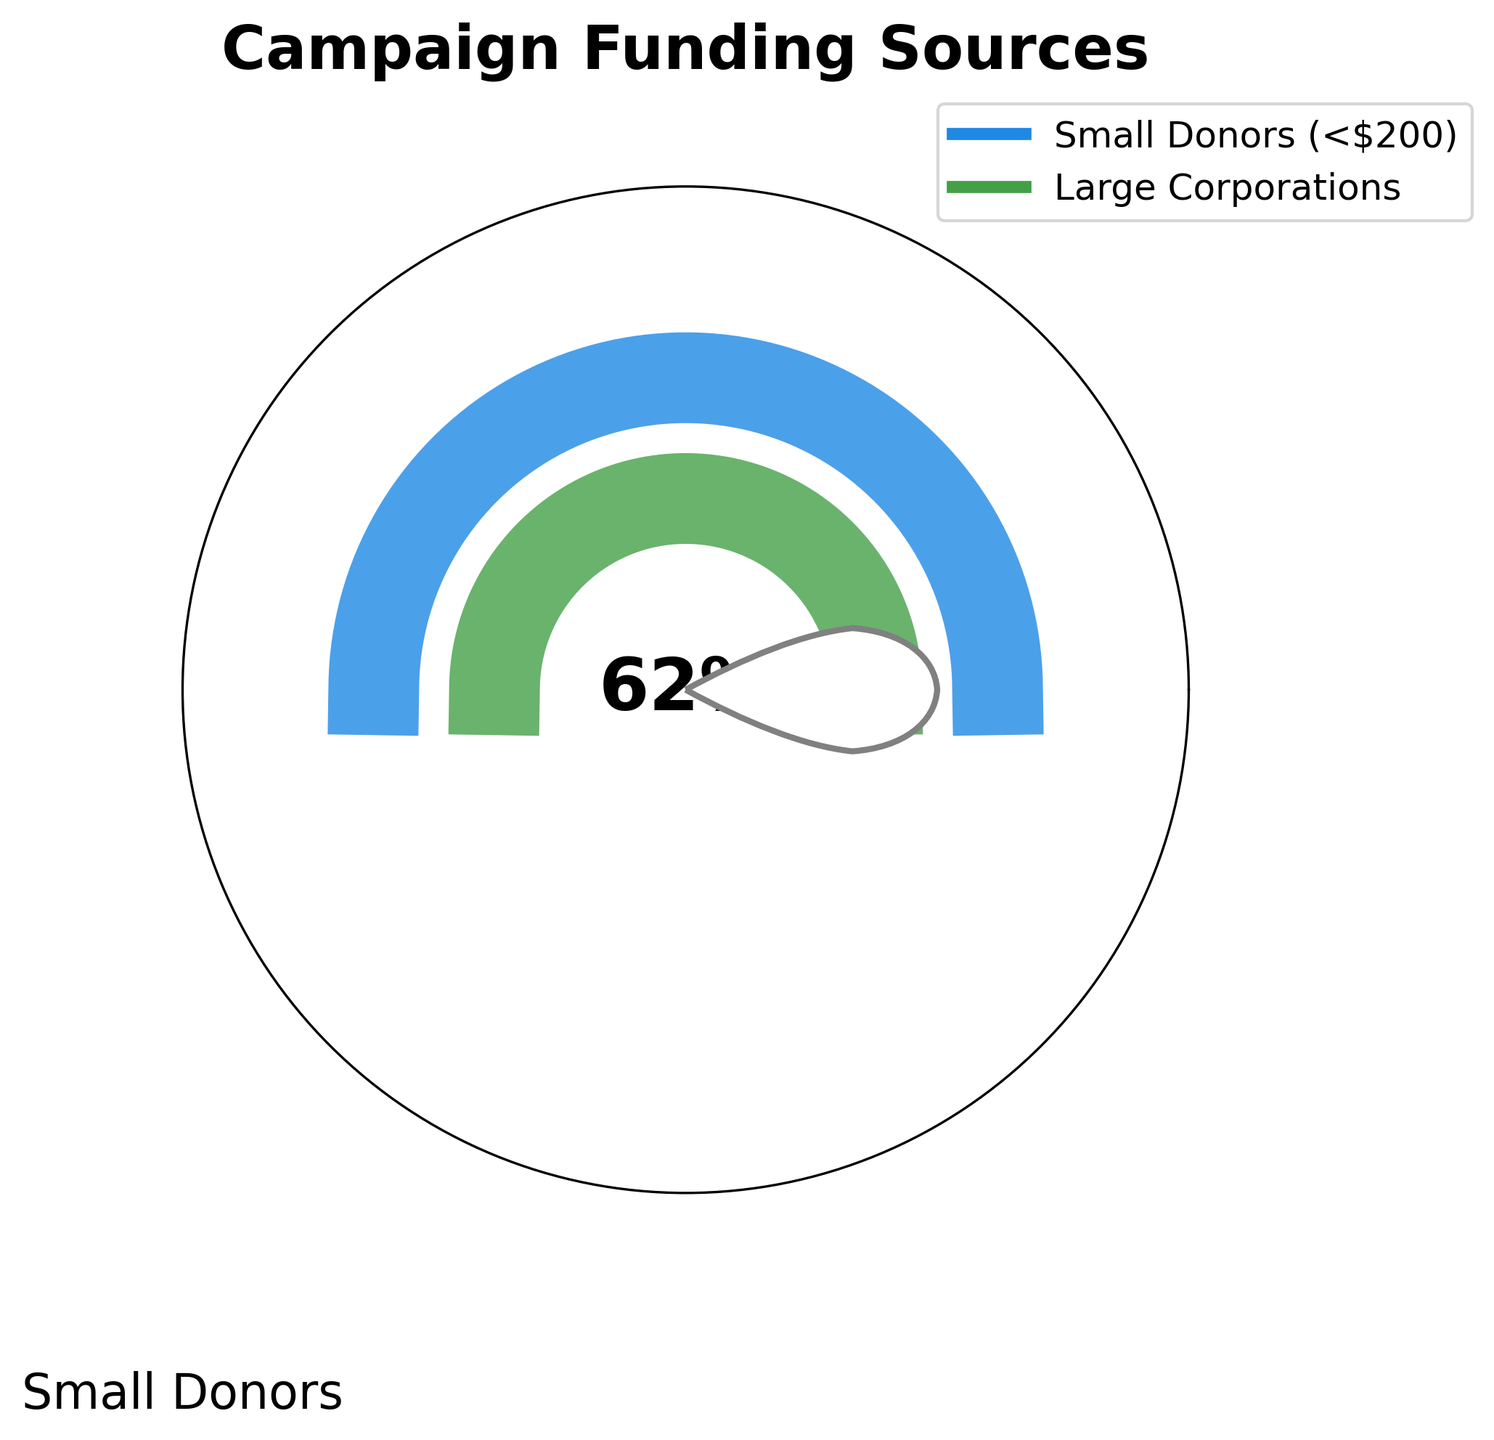what is the percentage of campaign funding from small donors? The figure shows a gauge chart with percentages for different categories. "Small Donors" is specified at 62% directly on the chart.
Answer: 62% what is the percentage of campaign funding from large corporations? The gauge chart displays the total percentage and splits it between categories. "Large Corporations" is specified at 38%.
Answer: 38% Which category has a higher percentage of campaign funding? By comparing the two percentages on the chart, 62% (Small Donors) is higher than 38% (Large Corporations).
Answer: Small Donors How much more funding comes from small donors compared to large corporations? We need to find the difference between the two percentages: 62% (Small Donors) - 38% (Large Corporations) = 24%.
Answer: 24% What total percentage is shown in the gauge chart? By adding the percentages from both categories shown on the chart, we see: 62% (Small Donors) + 38% (Large Corporations) = 100%.
Answer: 100% what color is used to represent small donors in the chart? The "Small Donors" segment on the gauge chart is marked in a blue color, according to the legend and its visual representation.
Answer: blue what color represents large corporations? The "Large Corporations" part of the gauge chart is marked in a green color, as indicated by the legend and visual depiction.
Answer: green Is the percentage of small donors greater than the percentage of large corporations? The chart indicates that 62% comes from Small Donors, which is greater than the 38% from Large Corporations.
Answer: Yes what is the difference between the fundraising percentages of each category? By subtracting the percentage of Large Corporations from Small Donors: 62% - 38% = 24%.
Answer: 24% What does the text in the center of the chart indicate? The number in the center of the chart reads "62%", corresponding to the percentage of funding from Small Donors.
Answer: 62% 